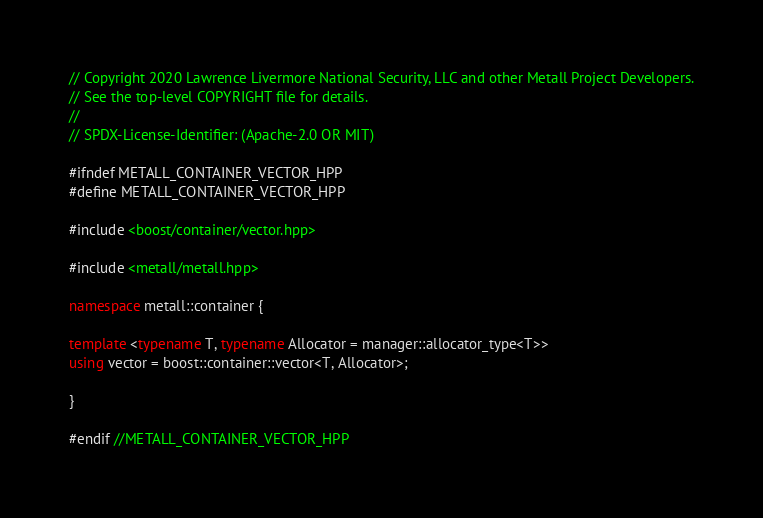Convert code to text. <code><loc_0><loc_0><loc_500><loc_500><_C++_>// Copyright 2020 Lawrence Livermore National Security, LLC and other Metall Project Developers.
// See the top-level COPYRIGHT file for details.
//
// SPDX-License-Identifier: (Apache-2.0 OR MIT)

#ifndef METALL_CONTAINER_VECTOR_HPP
#define METALL_CONTAINER_VECTOR_HPP

#include <boost/container/vector.hpp>

#include <metall/metall.hpp>

namespace metall::container {

template <typename T, typename Allocator = manager::allocator_type<T>>
using vector = boost::container::vector<T, Allocator>;

}

#endif //METALL_CONTAINER_VECTOR_HPP
</code> 